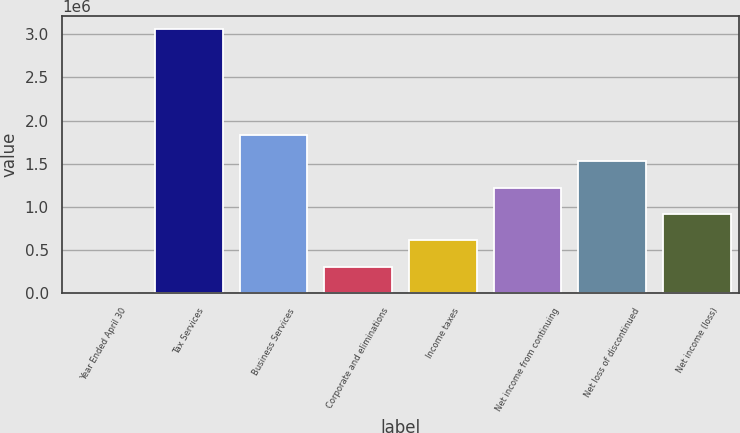Convert chart to OTSL. <chart><loc_0><loc_0><loc_500><loc_500><bar_chart><fcel>Year Ended April 30<fcel>Tax Services<fcel>Business Services<fcel>Corporate and eliminations<fcel>Income taxes<fcel>Net income from continuing<fcel>Net loss of discontinued<fcel>Net income (loss)<nl><fcel>2008<fcel>3.06066e+06<fcel>1.8372e+06<fcel>307873<fcel>613739<fcel>1.22547e+06<fcel>1.53133e+06<fcel>919604<nl></chart> 